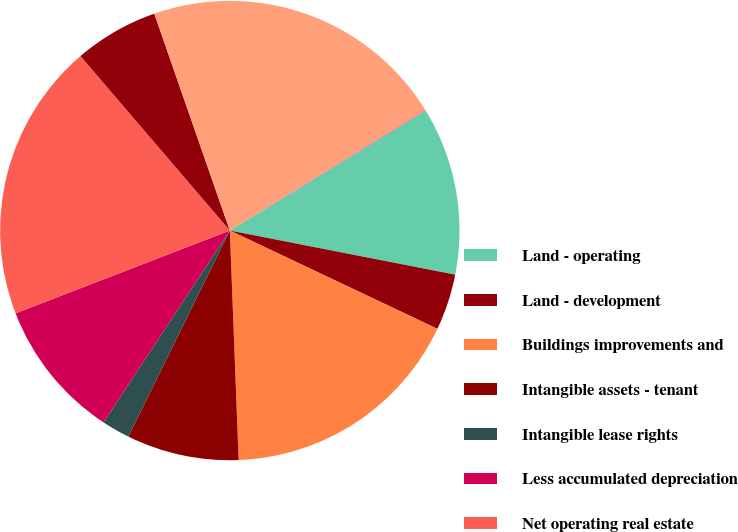Convert chart to OTSL. <chart><loc_0><loc_0><loc_500><loc_500><pie_chart><fcel>Land - operating<fcel>Land - development<fcel>Buildings improvements and<fcel>Intangible assets - tenant<fcel>Intangible lease rights<fcel>Less accumulated depreciation<fcel>Net operating real estate<fcel>Real estate under<fcel>Net real estate assets<fcel>Real estate assets held for<nl><fcel>11.82%<fcel>3.96%<fcel>17.35%<fcel>7.89%<fcel>1.99%<fcel>9.86%<fcel>19.6%<fcel>5.93%<fcel>21.56%<fcel>0.03%<nl></chart> 